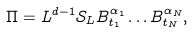Convert formula to latex. <formula><loc_0><loc_0><loc_500><loc_500>\Pi = L ^ { d - 1 } { \mathcal { S } } _ { L } B ^ { \alpha _ { 1 } } _ { t _ { 1 } } \dots B _ { t _ { N } } ^ { \alpha _ { N } } ,</formula> 